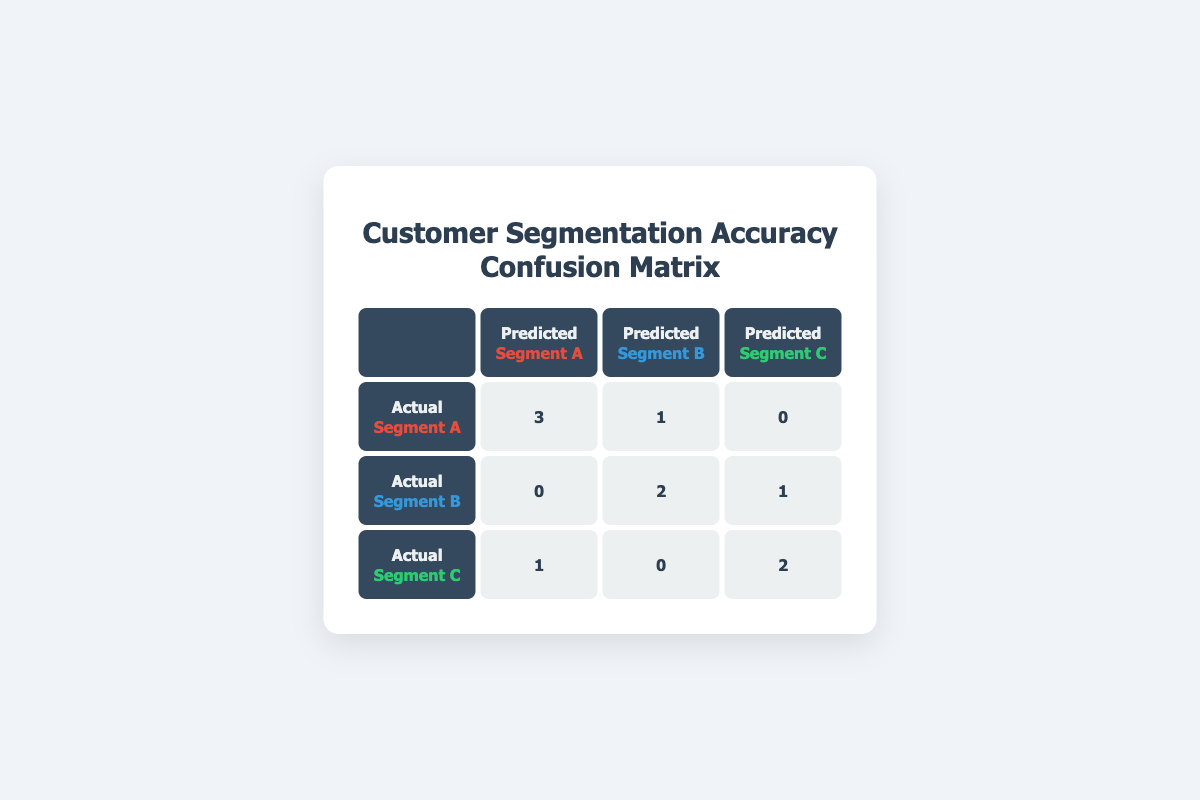What is the accuracy of predicting Segment A? To find the accuracy for Segment A, we look at the actual and predicted counts in the confusion matrix. The actual Segment A has 4 instances (3 correct predictions and 1 incorrect), so the accuracy is calculated as correct predictions divided by total actual predictions: 3/4 = 0.75 or 75%.
Answer: 75% How many actual customers were classified as Segment B? We can determine the actual customers in Segment B by looking at the confusion matrix. There are 3 instances of Segment B in the "Actual" row, with the values in their respective columns summing up to this: 0 (predicted A) + 2 (predicted B) + 1 (predicted C) = 3.
Answer: 3 What is the total number of customers predicted as Segment C? Looking at the confusion matrix, we can find the predicted Segment C values by summing the values in the "Predicted C" column: 0 (actual A) + 1 (actual B) + 2 (actual C) = 3.
Answer: 3 Did any predicted customers of Segment A come from Segment C? Observing the confusion matrix, we see that 0 customers from actual Segment C were predicted as Segment A. This indicates that there were no misclassifications from Segment C to Segment A.
Answer: No What is the total number of misclassifications for all segments? To find the total misclassifications, we need to look at all incorrect predictions. We can sum those values that do not align with actual labels: 1 (A as B) + 1 (C as A) + 1 (B as C) = 3 misclassifications.
Answer: 3 What is the ratio of correct predictions for Segment C to the total predictions made for Segment C? The correct predictions for Segment C are 2 (actual C predicted as C), and the total predictions for Segment C are 3 (1 from A, 0 from B, and 2 from C). Thus, we calculate the ratio: 2 correct/3 total = 2/3.
Answer: 2/3 Which segment had the highest number of correct predictions? Segment A has the highest number of correct predictions with 3 customers predicted accurately (3 actual A). Counting the other segments shows Segment B with 2 and Segment C with 2, confirming A is the highest.
Answer: Segment A What is the average number of actual customers for all segments? We find the total actual customers by summing up the values from all segments: Segment A (4) + Segment B (3) + Segment C (3) = 10. The average is then the total divided by the number of segments: 10/3 ≈ 3.33.
Answer: 3.33 